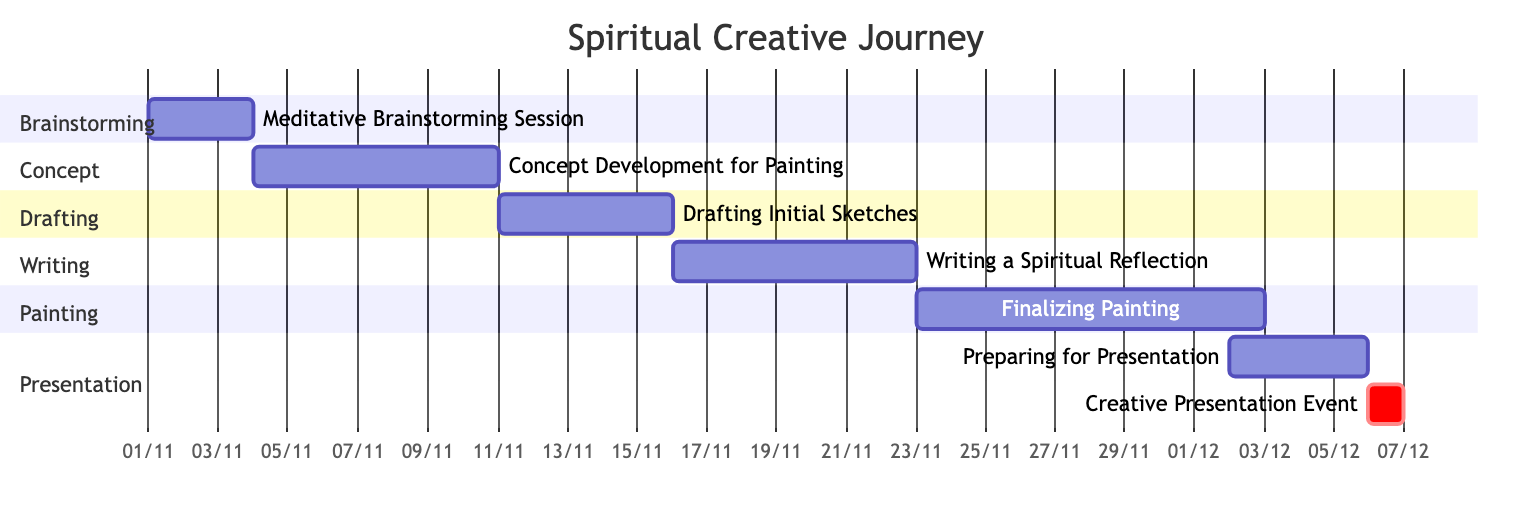What's the total number of tasks in the diagram? There are a total of 7 tasks listed in the Gantt chart. They include sessions for brainstorming, concept development, drafting, writing, painting, preparing for presentation, and the presentation event itself.
Answer: 7 What is the duration of the "Finalizing Painting" task? The "Finalizing Painting" task has a duration of 10 days, as indicated in the Gantt chart, which spans from November 23 to December 1.
Answer: 10 days Which task starts immediately after the "Drafting Initial Sketches"? "Writing a Spiritual Reflection" starts immediately after, as it begins on November 16, the day after "Drafting Initial Sketches" ends on November 15.
Answer: Writing a Spiritual Reflection Which section contains the "Creative Presentation Event"? The "Creative Presentation Event" is found in the "Presentation" section of the Gantt chart.
Answer: Presentation What is the start date of the "Preparing for Presentation" task? The "Preparing for Presentation" task starts on December 2, as shown in the chart, right before the "Creative Presentation Event."
Answer: December 2 How many days are between the end of "Concept Development for Painting" and the start of "Drafting Initial Sketches"? There are 1 day between the end of the "Concept Development for Painting" on November 10 and the start of "Drafting Initial Sketches" on November 11, indicating a transition day.
Answer: 1 day What is the purpose of the "Meditative Brainstorming Session"? The "Meditative Brainstorming Session" is intended to gather insights and inspiration through meditation and spontaneous journaling, as described.
Answer: Gather insights and inspiration What is the overlapping duration between "Preparing for Presentation" and "Finalizing Painting"? There is no overlapping duration between "Preparing for Presentation" and "Finalizing Painting" as they occur consecutively, with "Finalizing Painting" ending on December 1 and "Preparing for Presentation" starting on December 2.
Answer: 0 days 